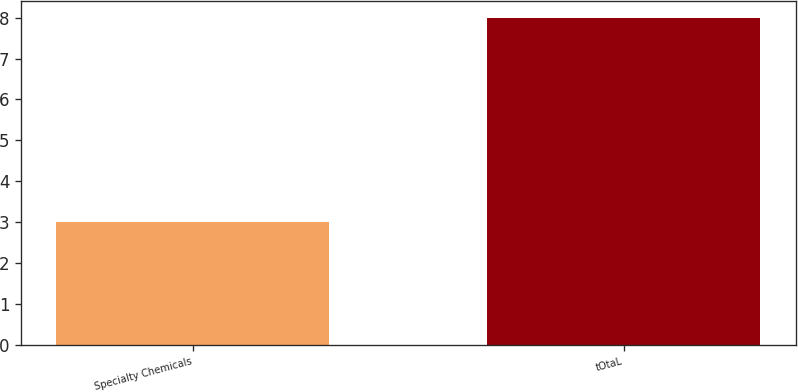Convert chart to OTSL. <chart><loc_0><loc_0><loc_500><loc_500><bar_chart><fcel>Specialty Chemicals<fcel>tOtaL<nl><fcel>3<fcel>8<nl></chart> 